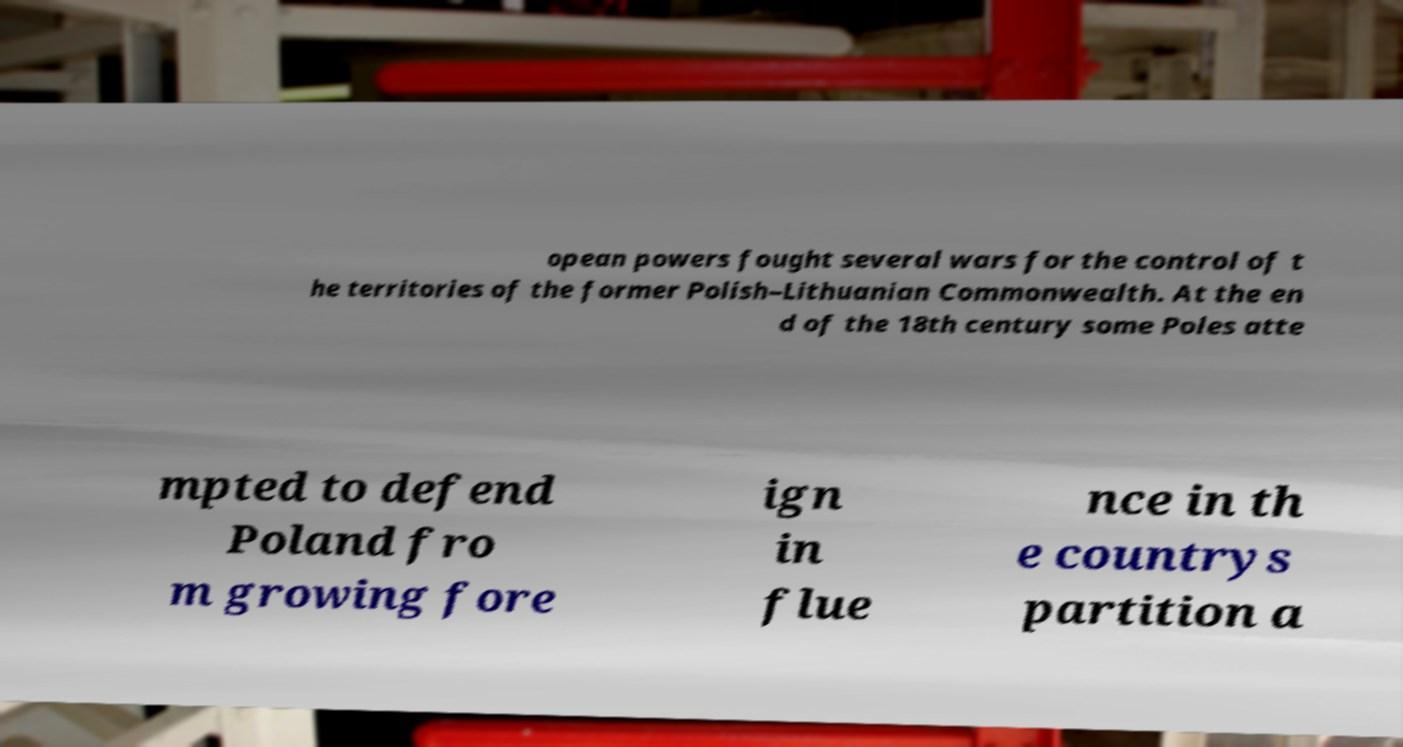I need the written content from this picture converted into text. Can you do that? opean powers fought several wars for the control of t he territories of the former Polish–Lithuanian Commonwealth. At the en d of the 18th century some Poles atte mpted to defend Poland fro m growing fore ign in flue nce in th e countrys partition a 